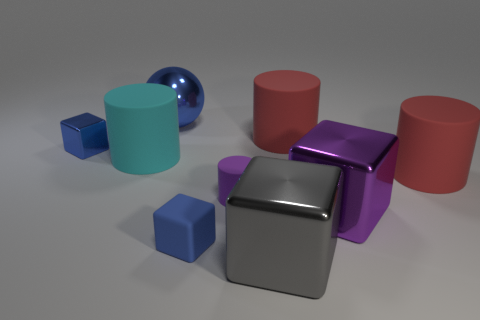What shape is the big gray shiny object in front of the purple thing that is behind the big purple thing?
Your answer should be compact. Cube. There is a big cyan object; how many metal blocks are on the right side of it?
Your answer should be compact. 2. The tiny cylinder that is the same material as the big cyan cylinder is what color?
Make the answer very short. Purple. Is the size of the purple cube the same as the shiny cube left of the big shiny sphere?
Offer a very short reply. No. What is the size of the metal cube behind the big red object that is to the right of the purple thing that is on the right side of the gray shiny cube?
Offer a terse response. Small. What number of matte objects are tiny cyan things or tiny objects?
Make the answer very short. 2. What color is the tiny matte object that is to the left of the small purple matte cylinder?
Keep it short and to the point. Blue. There is a cyan thing that is the same size as the purple metallic thing; what is its shape?
Your answer should be very brief. Cylinder. There is a large metallic sphere; does it have the same color as the cube that is on the left side of the big blue sphere?
Keep it short and to the point. Yes. How many things are things that are to the right of the big blue object or large things in front of the purple metallic cube?
Your response must be concise. 6. 